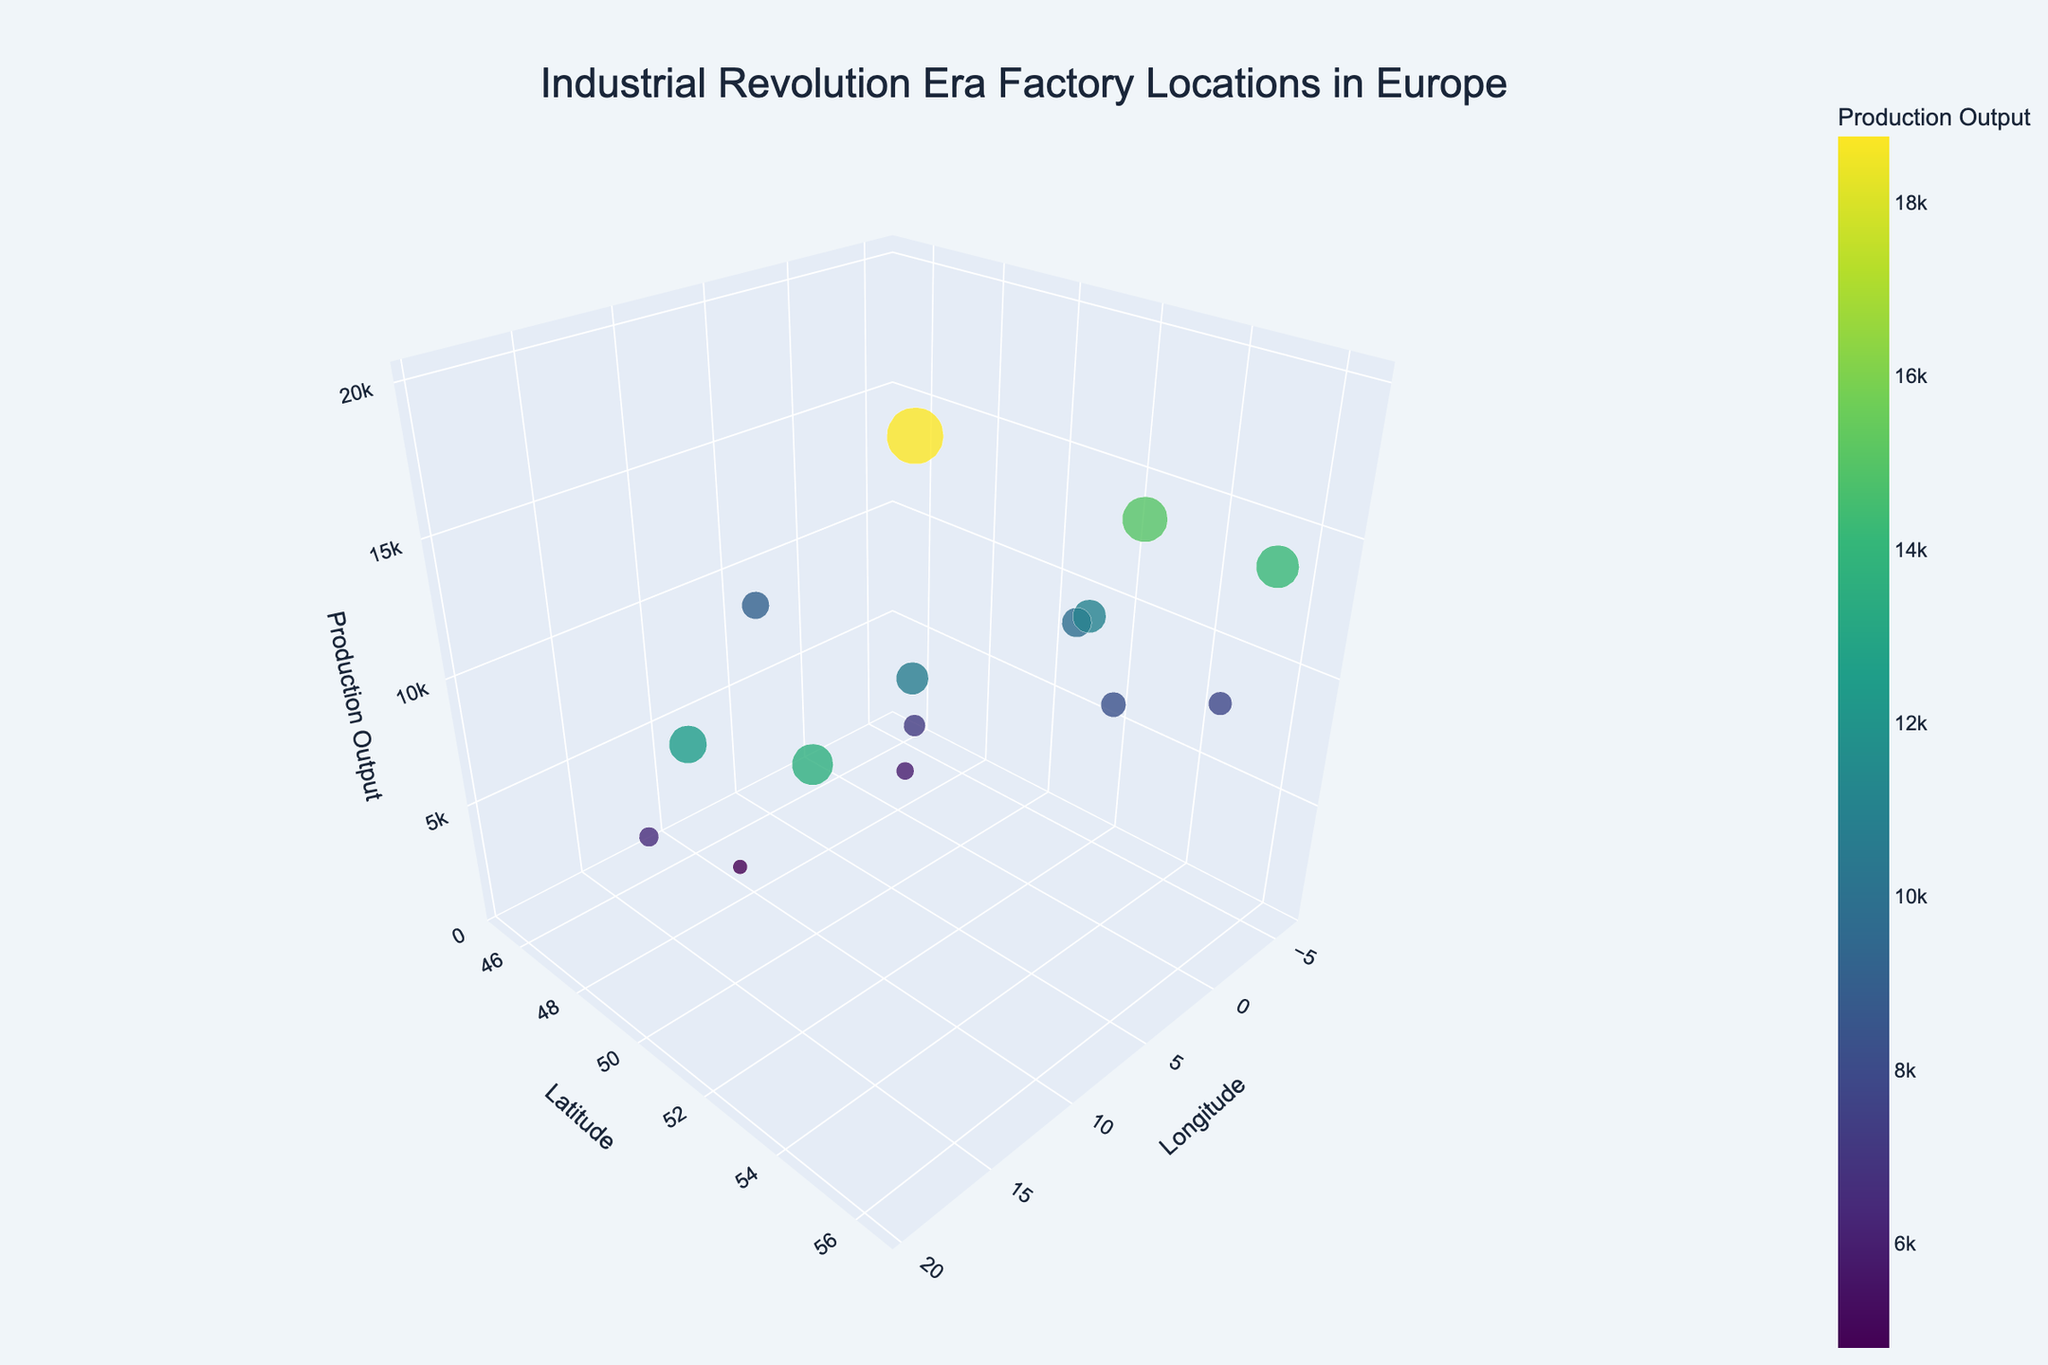What's the title of the figure? The title is usually found at the top center of the figure. In this case, it's provided in the layout update section of the code.
Answer: Industrial Revolution Era Factory Locations in Europe Which location has the highest production output? To determine this, look for the marker with the highest value along the z-axis (Production Output).
Answer: Krupp Steelworks Essen How many factories are represented in the figure? Count the total number of markers/data points shown on the plot.
Answer: 15 Which factory is located furthest north? Identify the marker with the highest value along the y-axis (Latitude).
Answer: Gdańsk Shipyard Compare the production output of the Manchester Cotton Mill and the Ruhr Valley Coal Mine. Which one has a higher production output? Examine the z-axis values of both factories to compare their outputs.
Answer: Manchester Cotton Mill Which factory is situated closest to Gdańsk Shipyard in terms of latitude and longitude? Compare the latitude and longitude of Gdańsk Shipyard with other factories to find the nearest one.
Answer: Belfast Linen Mill What is the combined production output of Łódź Textile Mill and Glasgow Shipyard? Add the production outputs of Łódź Textile Mill (12500) and Glasgow Shipyard (14200) to get the combined output.
Answer: 26700 Which two factories have a production output difference of approximately 7000? Calculate the differences between all pairs and find the pair that approximates a difference of 7000.
Answer: Manchester Cotton Mill and Liège Armory What's the average production output of the factories located in the UK? Sum the outputs of UK factories (Manchester Cotton Mill, Rhondda Valley Coal Mine, Birmingham Metalworks, Sheffield Cutlery Works, Glasgow Shipyard, Belfast Linen Mill) and divide by the number of these factories.
Answer: 10950 Is the production output higher in eastern or western Europe? Compare the sum of production outputs for factories located east of the 10° longitude line (eastern Europe) vs. those located west (western Europe).
Answer: Western Europe 